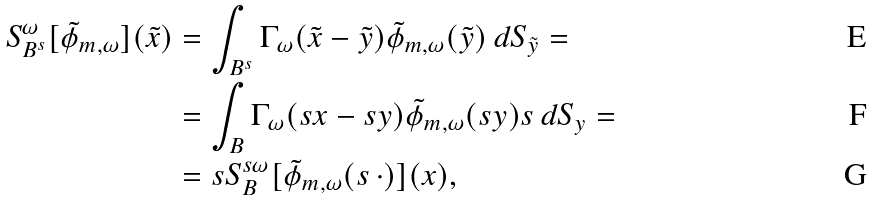<formula> <loc_0><loc_0><loc_500><loc_500>S ^ { \omega } _ { B ^ { s } } [ \tilde { \phi } _ { m , \omega } ] ( \tilde { x } ) & = \int _ { B ^ { s } } \Gamma _ { \omega } ( \tilde { x } - \tilde { y } ) \tilde { \phi } _ { m , \omega } ( \tilde { y } ) \, d S _ { \tilde { y } } = \\ & = \int _ { B } \Gamma _ { \omega } ( s x - s y ) \tilde { \phi } _ { m , \omega } ( s y ) s \, d S _ { y } = \\ & = s S ^ { s \omega } _ { B } [ \tilde { \phi } _ { m , \omega } ( s \, \cdot ) ] ( x ) ,</formula> 